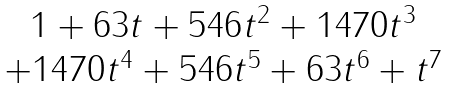Convert formula to latex. <formula><loc_0><loc_0><loc_500><loc_500>\begin{matrix} 1 + 6 3 t + 5 4 6 t ^ { 2 } + 1 4 7 0 t ^ { 3 } \\ + 1 4 7 0 t ^ { 4 } + 5 4 6 t ^ { 5 } + 6 3 t ^ { 6 } + t ^ { 7 } \end{matrix}</formula> 